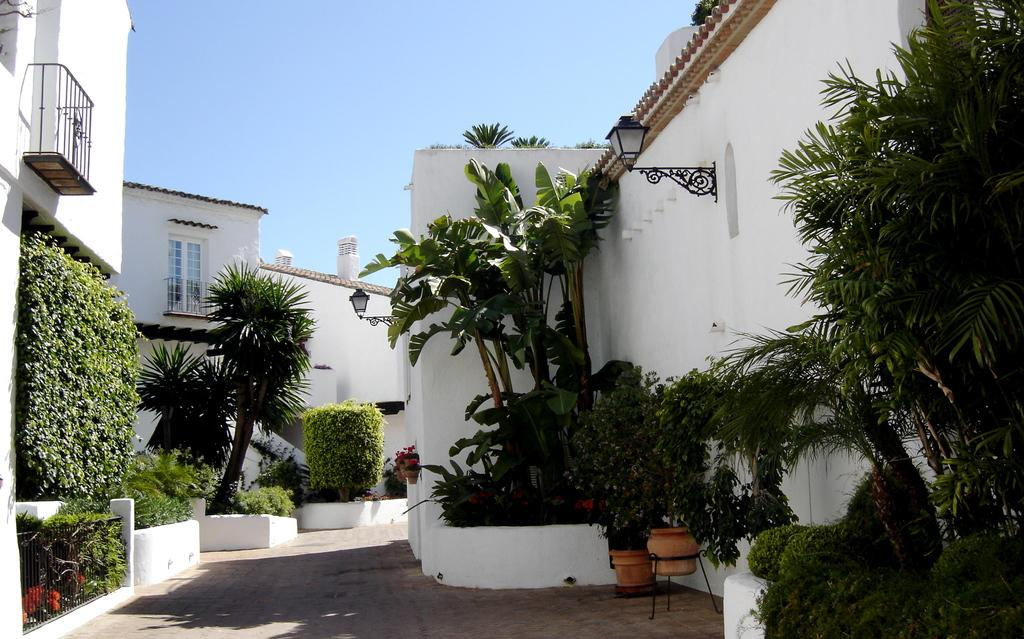What type of plants can be seen in the image? There are house plants in the image. What other vegetation is present in the image? There are trees in the image. What type of structures are visible in the image? There are buildings with windows in the image. What type of lighting is present in the image? There are lamps in the image. What can be seen in the background of the image? The sky is visible in the background of the image. What is the condition of the office in the image? There is no office present in the image; it features house plants, trees, buildings, lamps, and the sky. Can you describe the face of the person in the image? There is no person present in the image, so it is not possible to describe their face. 